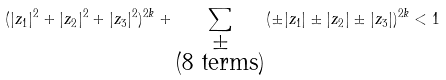<formula> <loc_0><loc_0><loc_500><loc_500>( | z _ { 1 } | ^ { 2 } + | z _ { 2 } | ^ { 2 } + | z _ { 3 } | ^ { 2 } ) ^ { 2 k } + \sum _ { \substack { \pm \\ \text {(8 terms)} } } ( \pm | z _ { 1 } | \pm | z _ { 2 } | \pm | z _ { 3 } | ) ^ { 2 k } < 1</formula> 